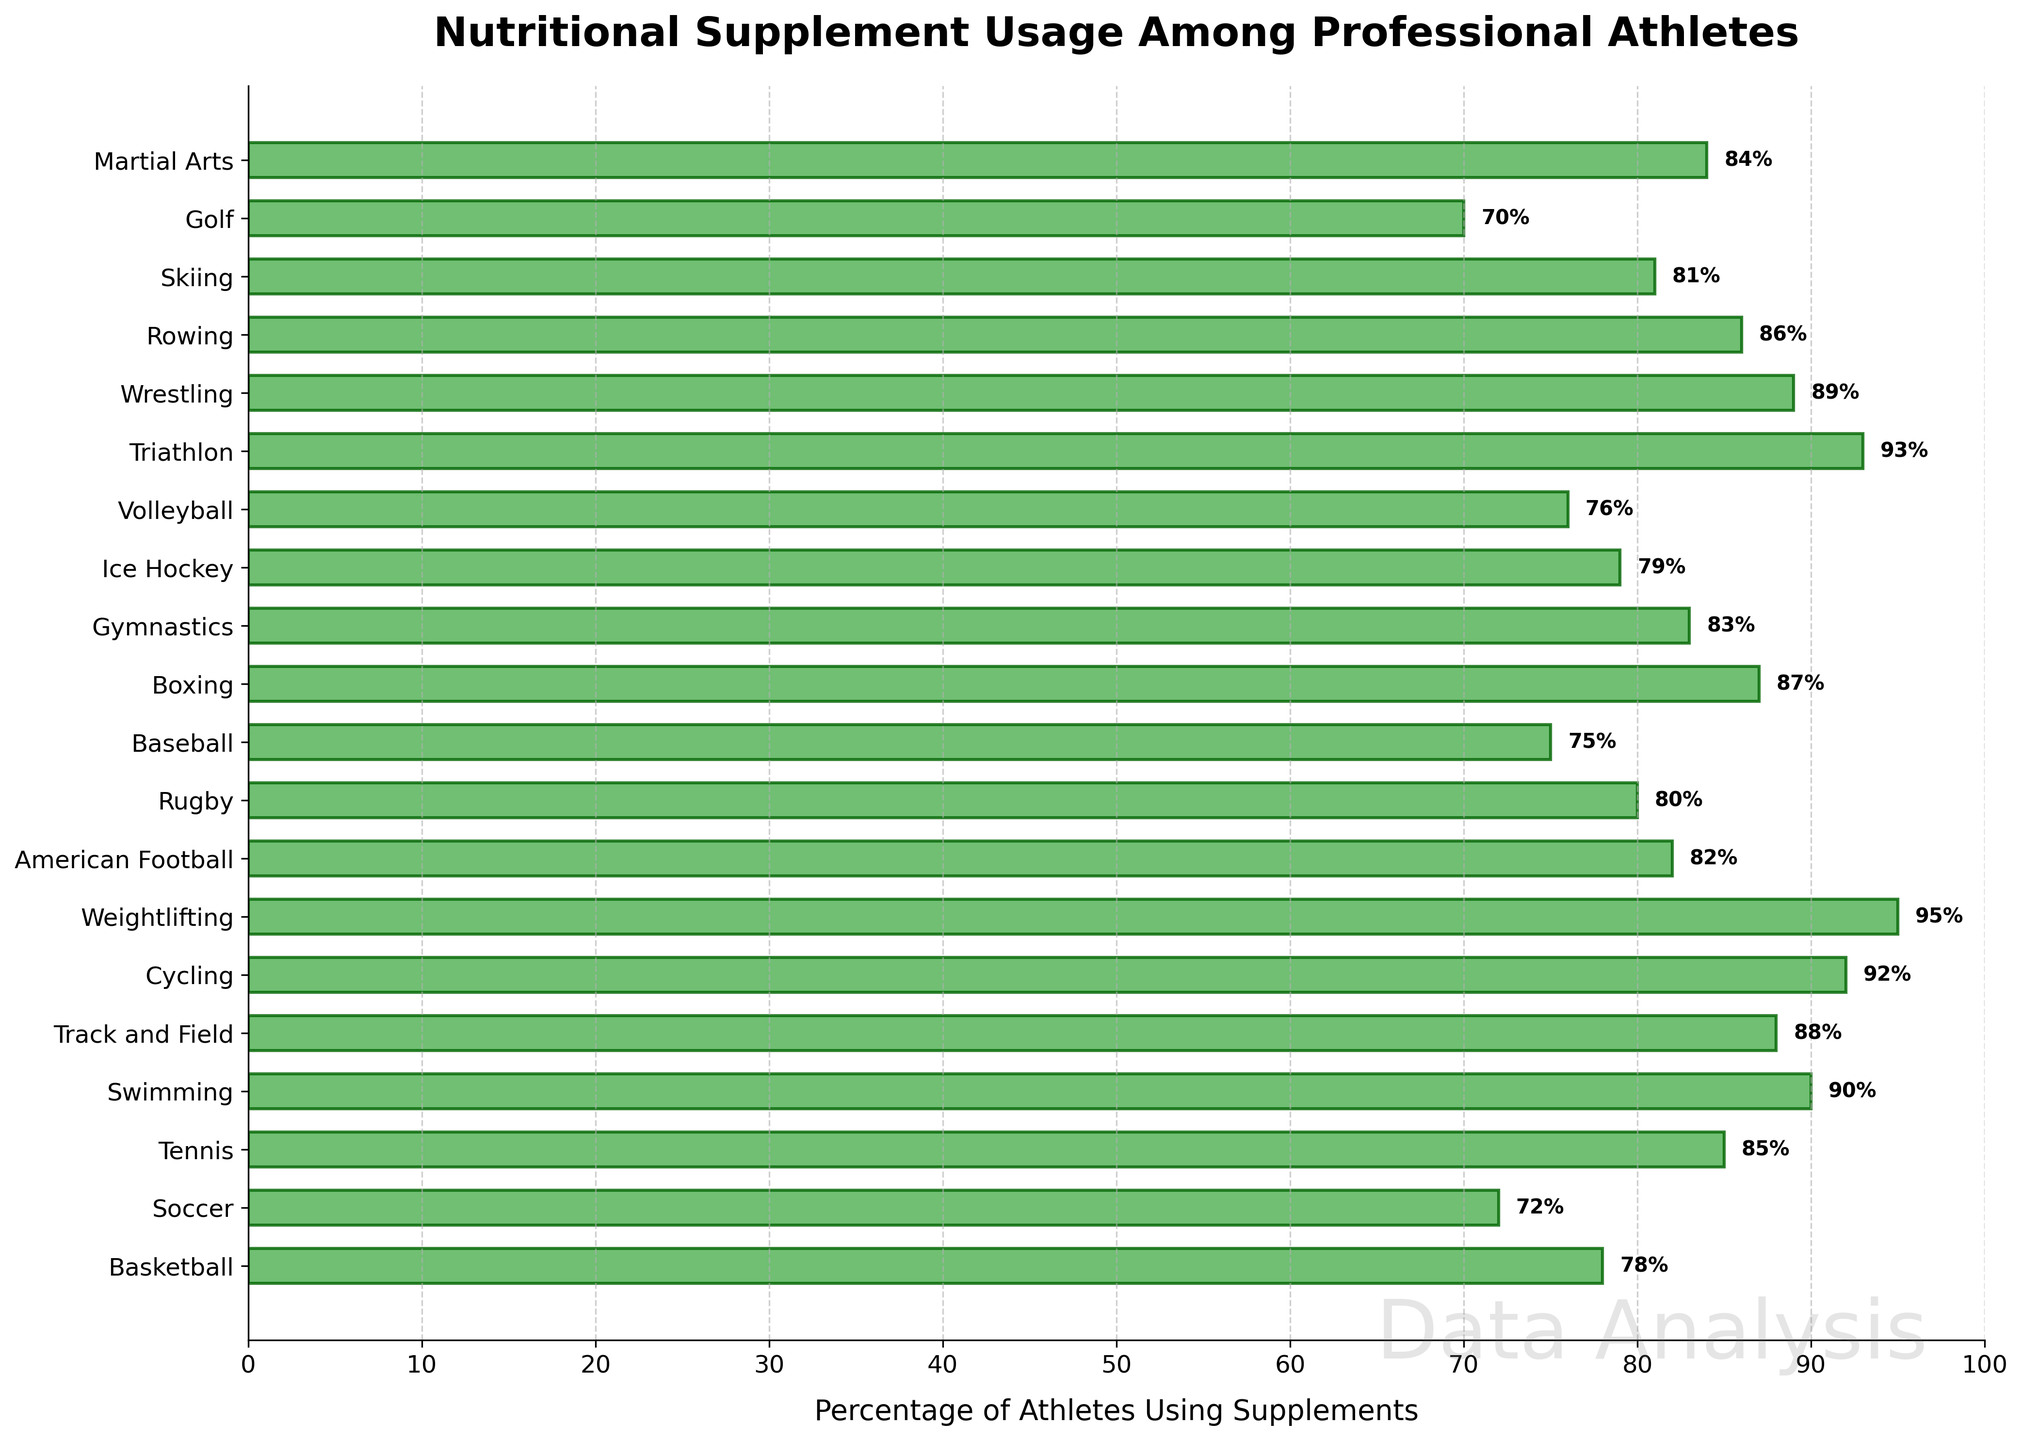What sport has the highest percentage of athletes using supplements? By looking at the chart, identify the bar with the highest endpoint. The label corresponding to this bar is the sport with the highest percentage of athletes using supplements.
Answer: Weightlifting What is the difference in supplement usage between Soccer and Swimming? Find the percentage values for Soccer (72%) and Swimming (90%) from the chart, then subtract the smaller value from the larger one.
Answer: 18% Which sports have more than 85% of athletes using supplements? Identify the bars that extend beyond the 85% mark and note the corresponding sport labels.
Answer: Tennis, Swimming, Track and Field, Cycling, Weightlifting, Boxing, Triathlon, Wrestling What is the average percentage of supplement usage among American Football, Rugby, and Ice Hockey? Find the percentage values for American Football (82%), Rugby (80%), and Ice Hockey (79%), then calculate the mean: (82 + 80 + 79) / 3 = 80.33.
Answer: 80.33% Which sport has the smallest percentage of athletes using supplements and how much is it? Find the bar with the smallest length and read the corresponding percentage value from the label.
Answer: Golf, 70% Is the percentage of athletes using supplements in Gymnastics higher than in Ice Hockey? Compare the lengths of the bars for Gymnastics (83%) and Ice Hockey (79%). Gymnastics has a higher percentage.
Answer: Yes What is the total percentage of athletes using supplements for Tennis, Rowing, and Martial Arts combined? Add the percentage values for Tennis (85%), Rowing (86%), and Martial Arts (84%): 85 + 86 + 84 = 255.
Answer: 255% Which sports have a percentage of athletes using supplements that is exactly 82%? Identify the bars with a value of 82% and note the corresponding sport labels.
Answer: American Football What is the median percentage usage value of all sports listed? Arrange all the percentages in numerical order and find the middle value. For an even number of entries, take the average of the two central numbers. The ordered percentages are: [70, 72, 75, 76, 78, 79, 80, 81, 82, 83, 84, 85, 86, 87, 88, 89, 90, 92, 93, 95]. The median is the average of 83 and 84, which is 83.5.
Answer: 83.5 How many sports have a supplement usage percentage between 75% and 85%? Count the number of sports that fall within the given range by examining the bar chart values.
Answer: 8 